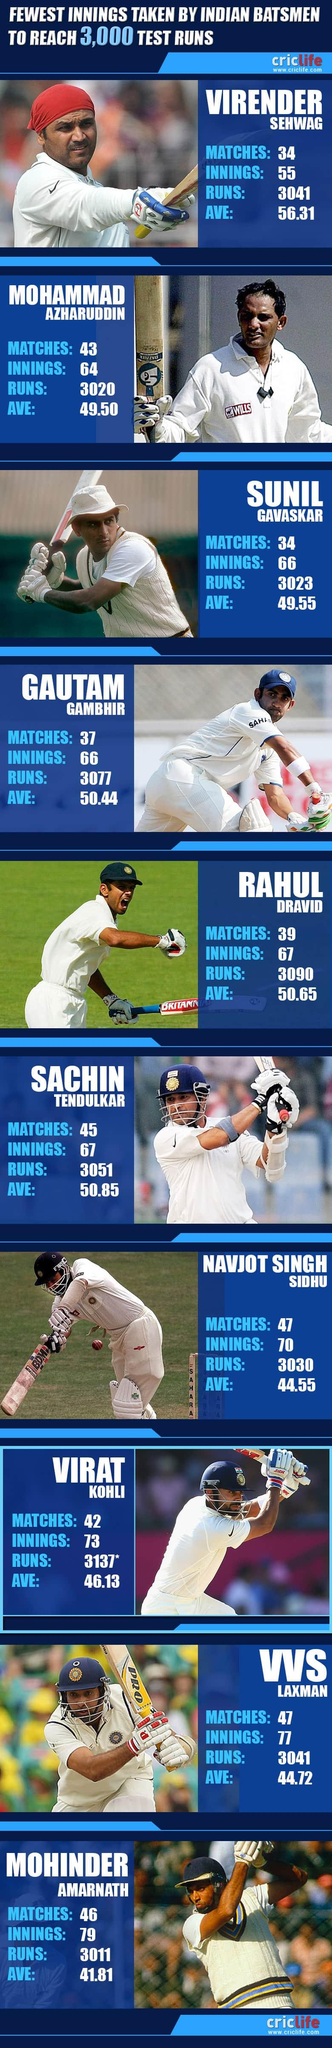Outline some significant characteristics in this image. The second highest batting average was 50.85. The highest number of runs taken was 3137. 